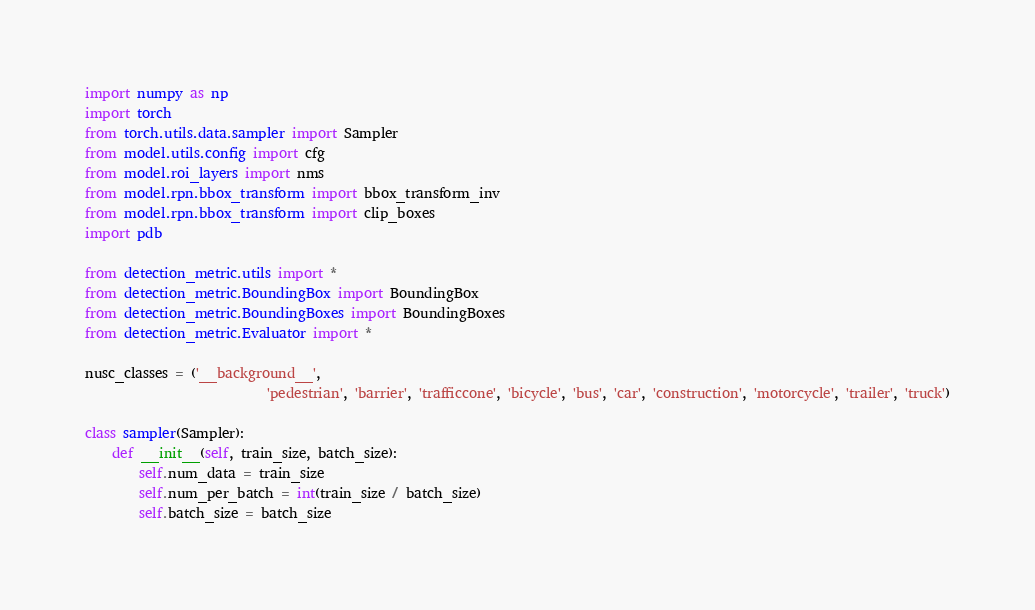Convert code to text. <code><loc_0><loc_0><loc_500><loc_500><_Python_>import numpy as np
import torch
from torch.utils.data.sampler import Sampler
from model.utils.config import cfg
from model.roi_layers import nms
from model.rpn.bbox_transform import bbox_transform_inv
from model.rpn.bbox_transform import clip_boxes
import pdb

from detection_metric.utils import *
from detection_metric.BoundingBox import BoundingBox
from detection_metric.BoundingBoxes import BoundingBoxes
from detection_metric.Evaluator import *

nusc_classes = ('__background__', 
                           'pedestrian', 'barrier', 'trafficcone', 'bicycle', 'bus', 'car', 'construction', 'motorcycle', 'trailer', 'truck')
                           
class sampler(Sampler):
    def __init__(self, train_size, batch_size):
        self.num_data = train_size
        self.num_per_batch = int(train_size / batch_size)
        self.batch_size = batch_size</code> 